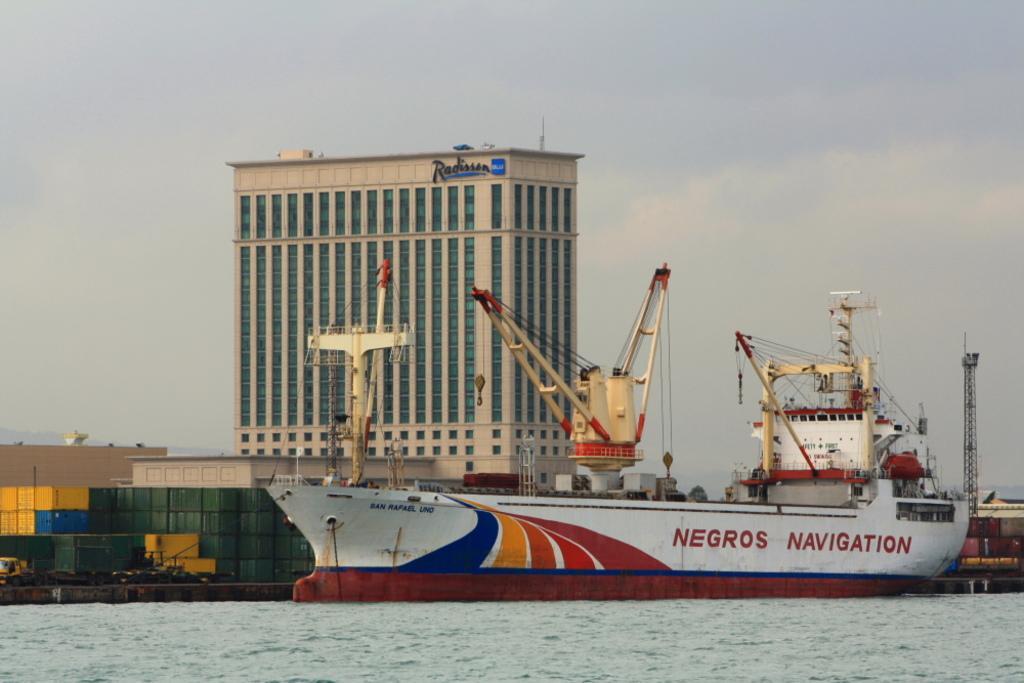Can you describe this image briefly? In this picture there is a ship on the water and there is a text on the ship. At the back there are containers and there is a building and there is a text on the building. At the top there is sky and there are clouds. At the bottom there is water. 